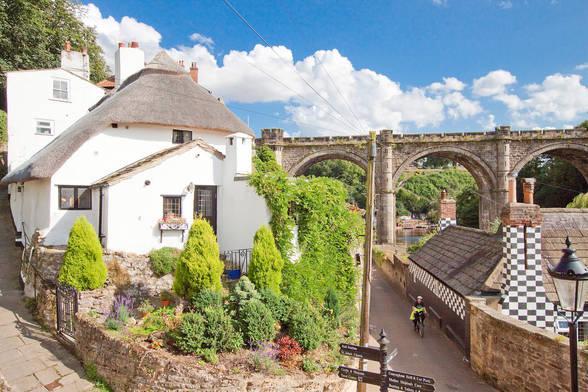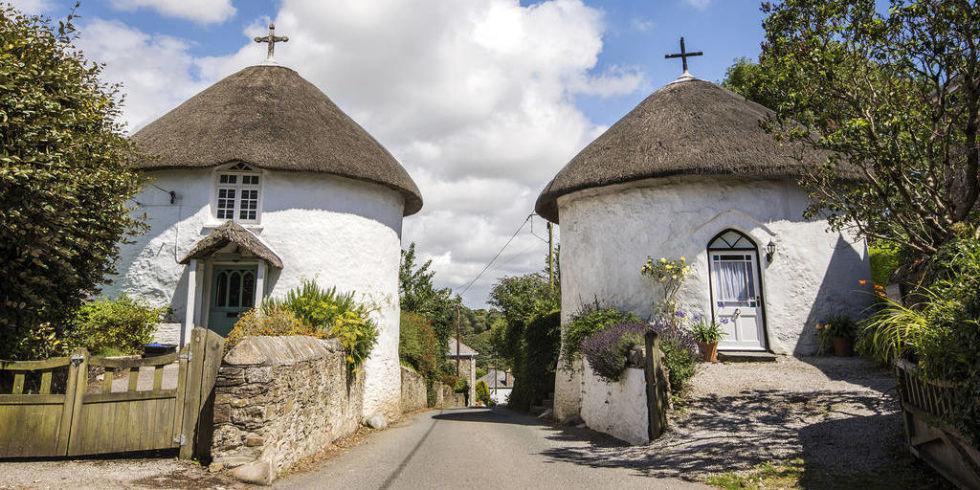The first image is the image on the left, the second image is the image on the right. Given the left and right images, does the statement "In at least one image there is a house that is white with a blackish roof and a chimney on the left side of the house." hold true? Answer yes or no. No. The first image is the image on the left, the second image is the image on the right. Given the left and right images, does the statement "The right image is a head-on view of a white building with at least two notches in the roofline to accommodate upper story windows and at least one pyramid roof shape projecting at the front of the house." hold true? Answer yes or no. No. 